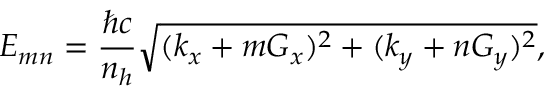Convert formula to latex. <formula><loc_0><loc_0><loc_500><loc_500>E _ { m n } = \frac { \hbar { c } } { n _ { h } } \sqrt { ( k _ { x } + m G _ { x } ) ^ { 2 } + ( k _ { y } + n G _ { y } ) ^ { 2 } } ,</formula> 